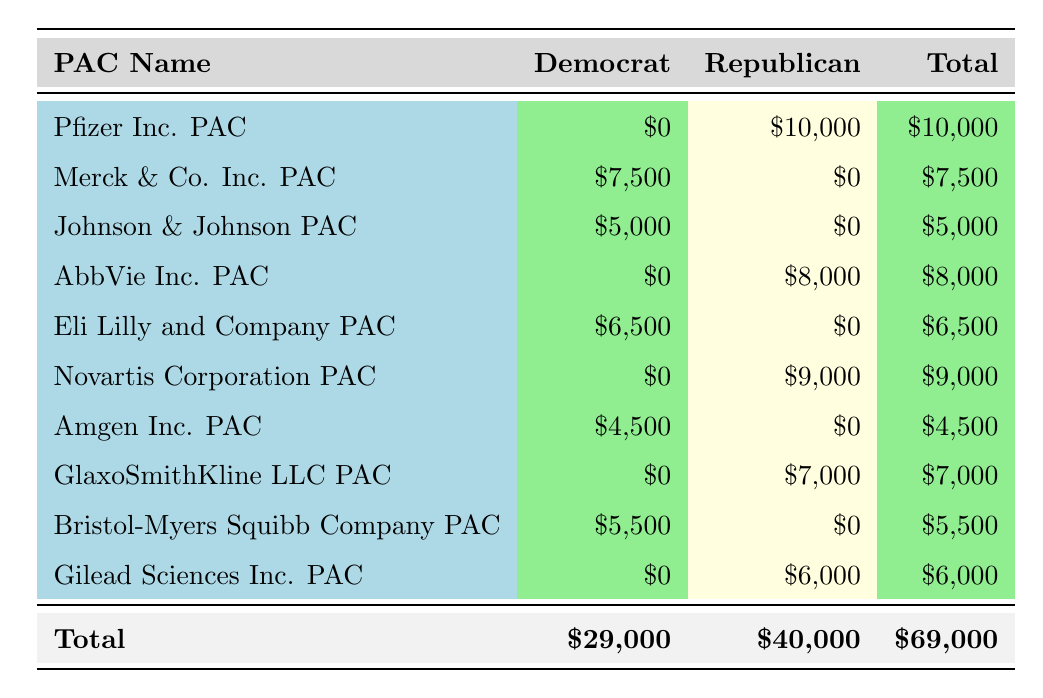What is the total amount contributed by Republican PACs? To find the total contributions from Republican PACs, sum the amounts in the Republican column: 10,000 (Pfizer) + 8,000 (AbbVie) + 9,000 (Novartis) + 7,000 (GlaxoSmithKline) + 6,000 (Gilead) = 40,000.
Answer: 40,000 What is the total amount contributed by Democratic PACs? For the total contributions from Democratic PACs, sum the amounts in the Democratic column: 7,500 (Merck) + 5,000 (Johnson & Johnson) + 6,500 (Eli Lilly) + 4,500 (Amgen) + 5,500 (Bristol-Myers Squibb) = 29,000.
Answer: 29,000 Which PAC contributed the highest amount in total? Assess each PAC's total contribution. Pfizer contributed 10,000, AbbVie 8,000, Novartis 9,000, etc. The highest contribution is from Pfizer with 10,000.
Answer: Pfizer Inc. PAC Did any PACs contribute to both a Democrat and a Republican? Checking the table reveals that all contributions from the PACs are either exclusively to Democrats or Republicans. Therefore, no PACs contributed to both.
Answer: No How much less did Democratic PACs contribute compared to Republican PACs? To find the difference, subtract the total amount of Democratic PACs from the total amount of Republican PACs: 40,000 (Republican) - 29,000 (Democrat) = 11,000.
Answer: 11,000 What percentage of the total contributions came from Democratic PACs? Calculate the percentage by dividing the total contributions from Democratic PACs (29,000) by the overall total (69,000) and then multiply by 100: (29,000/69,000) * 100 ≈ 42.03.
Answer: 42.03 Which state had the highest contribution from a single PAC? Compare the contributions by state. The highest single contribution is from Pfizer Inc. PAC in Kentucky with 10,000.
Answer: Kentucky How many PACs contributed to each party? There are 5 Democratic PACs and 5 Republican PACs listed in the table, confirmed by counting the rows under each party separately.
Answer: 5 Democratic, 5 Republican 